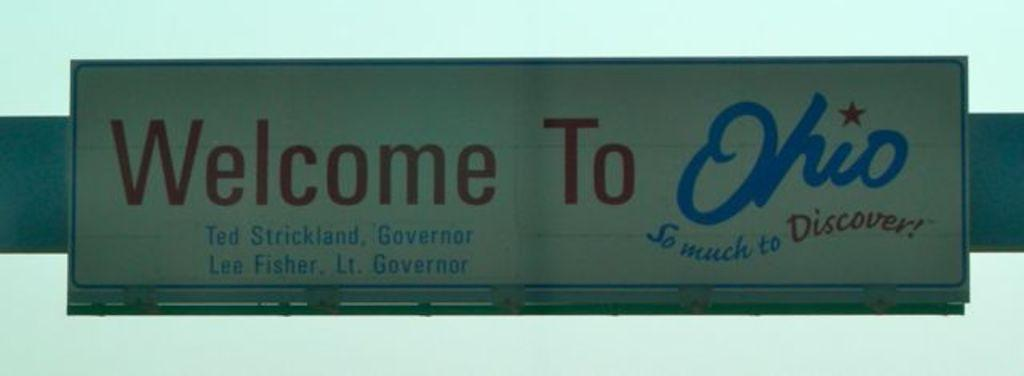Provide a one-sentence caption for the provided image. A road sign that reads Welcome to Ohio is displayed with red and blue letters on a white background. 